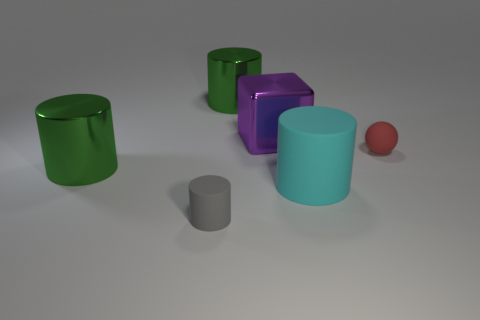Subtract 1 cylinders. How many cylinders are left? 3 Subtract all blue cylinders. Subtract all gray balls. How many cylinders are left? 4 Add 4 large blocks. How many objects exist? 10 Subtract all cubes. How many objects are left? 5 Subtract 0 green balls. How many objects are left? 6 Subtract all tiny red matte spheres. Subtract all red objects. How many objects are left? 4 Add 1 tiny red rubber objects. How many tiny red rubber objects are left? 2 Add 2 small brown rubber objects. How many small brown rubber objects exist? 2 